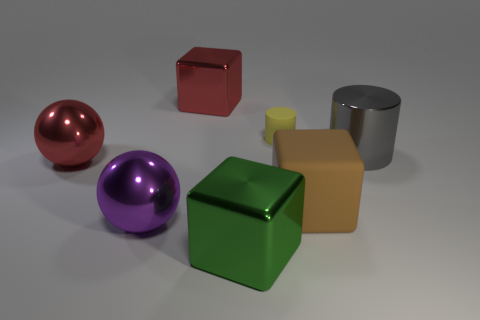Are there any other things that have the same size as the matte cylinder?
Your response must be concise. No. There is a large object that is both behind the red shiny ball and right of the red metallic cube; what material is it made of?
Keep it short and to the point. Metal. The green object that is the same material as the big purple sphere is what shape?
Make the answer very short. Cube. Do the big cube that is behind the small rubber cylinder and the big brown thing have the same material?
Provide a succinct answer. No. There is a cylinder that is left of the big matte cube; what material is it?
Offer a very short reply. Rubber. How big is the red object that is to the right of the metal sphere that is in front of the brown object?
Your answer should be very brief. Large. How many green things have the same size as the purple shiny thing?
Make the answer very short. 1. There is a metal block that is behind the brown thing; is it the same color as the big metal sphere that is behind the large purple thing?
Give a very brief answer. Yes. There is a brown matte object; are there any green metal things behind it?
Ensure brevity in your answer.  No. What is the color of the big shiny object that is both on the left side of the yellow cylinder and on the right side of the red metallic block?
Give a very brief answer. Green. 